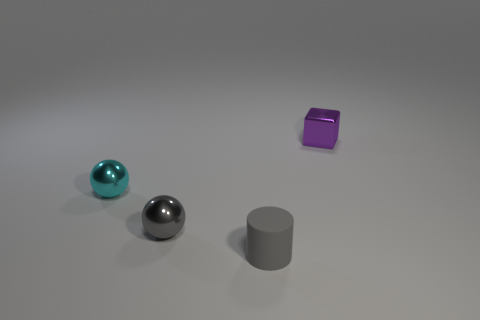Add 4 large blue things. How many objects exist? 8 Subtract all metallic things. Subtract all tiny purple things. How many objects are left? 0 Add 1 purple cubes. How many purple cubes are left? 2 Add 2 cylinders. How many cylinders exist? 3 Subtract 0 brown cubes. How many objects are left? 4 Subtract all yellow balls. Subtract all cyan cubes. How many balls are left? 2 Subtract all cyan cubes. How many cyan spheres are left? 1 